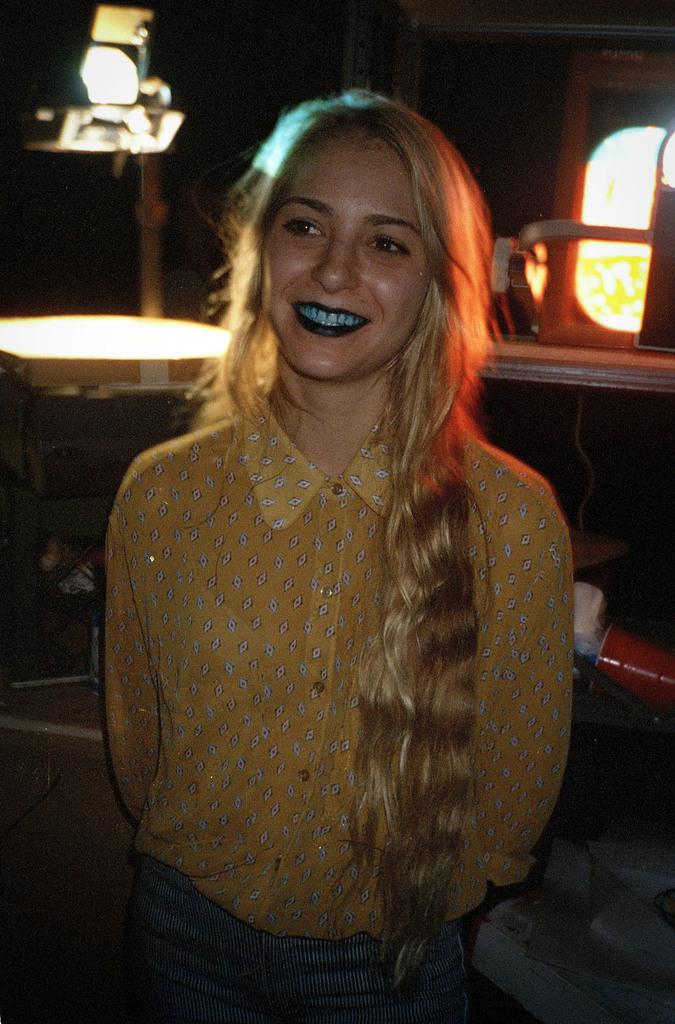Who is present in the image? There is a woman in the image. What is the woman doing in the image? The woman is standing in the image. What is the woman's facial expression in the image? The woman is smiling in the image. What can be seen in the background of the image? There is a light in the background of the image. What type of dress is the woman wearing in the image? The provided facts do not mention the type of dress the woman is wearing, so we cannot answer this question definitively. 